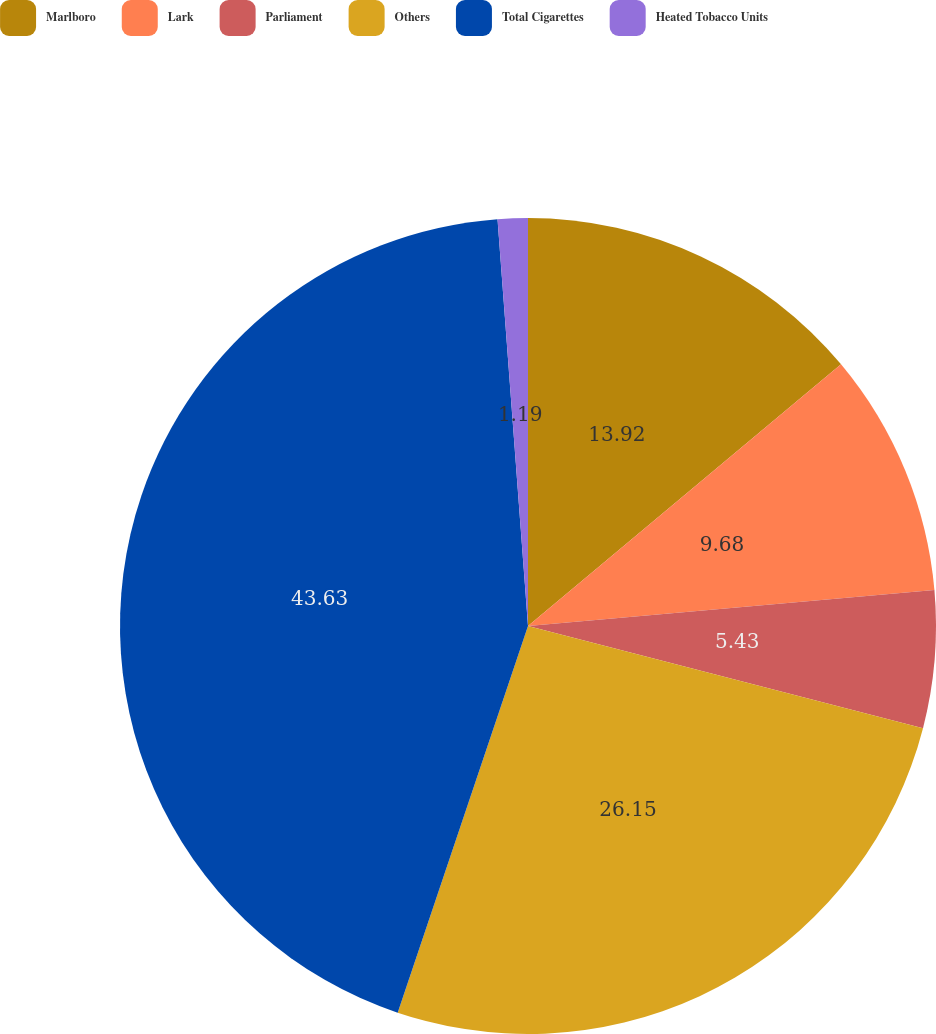Convert chart to OTSL. <chart><loc_0><loc_0><loc_500><loc_500><pie_chart><fcel>Marlboro<fcel>Lark<fcel>Parliament<fcel>Others<fcel>Total Cigarettes<fcel>Heated Tobacco Units<nl><fcel>13.92%<fcel>9.68%<fcel>5.43%<fcel>26.15%<fcel>43.64%<fcel>1.19%<nl></chart> 